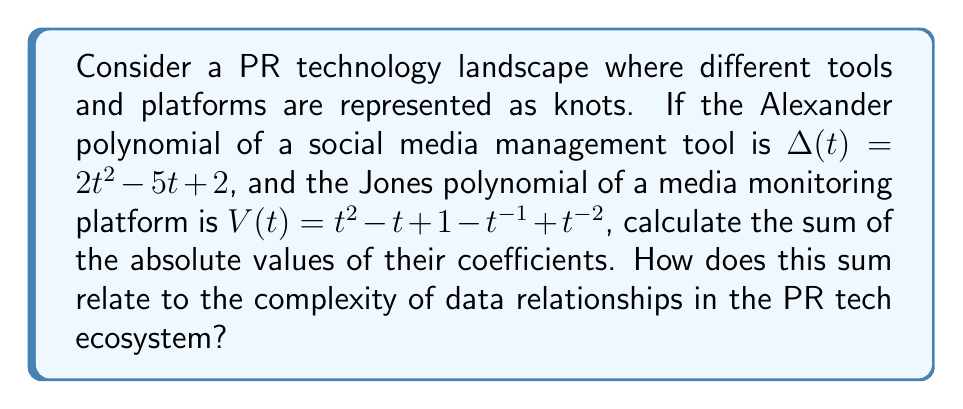Give your solution to this math problem. 1. First, let's identify the coefficients of each polynomial:

   Alexander polynomial: $\Delta(t) = 2t^2 - 5t + 2$
   Coefficients: 2, -5, 2

   Jones polynomial: $V(t) = t^2 - t + 1 - t^{-1} + t^{-2}$
   Coefficients: 1, -1, 1, -1, 1

2. Calculate the absolute values of these coefficients:
   
   Alexander polynomial: |2|, |-5|, |2| = 2, 5, 2
   Jones polynomial: |1|, |-1|, |1|, |-1|, |1| = 1, 1, 1, 1, 1

3. Sum the absolute values:
   
   Alexander polynomial sum: 2 + 5 + 2 = 9
   Jones polynomial sum: 1 + 1 + 1 + 1 + 1 = 5

4. Total sum: 9 + 5 = 14

5. Interpretation: In knot theory, the sum of absolute values of coefficients in knot polynomials often correlates with the complexity of the knot. In our PR tech analogy, this sum (14) represents the combined complexity of data relationships in the social media management tool and media monitoring platform. A higher sum suggests more intricate data interactions and potentially more sophisticated functionality in the PR tech ecosystem.
Answer: 14; higher sum indicates greater complexity in PR tech data relationships 